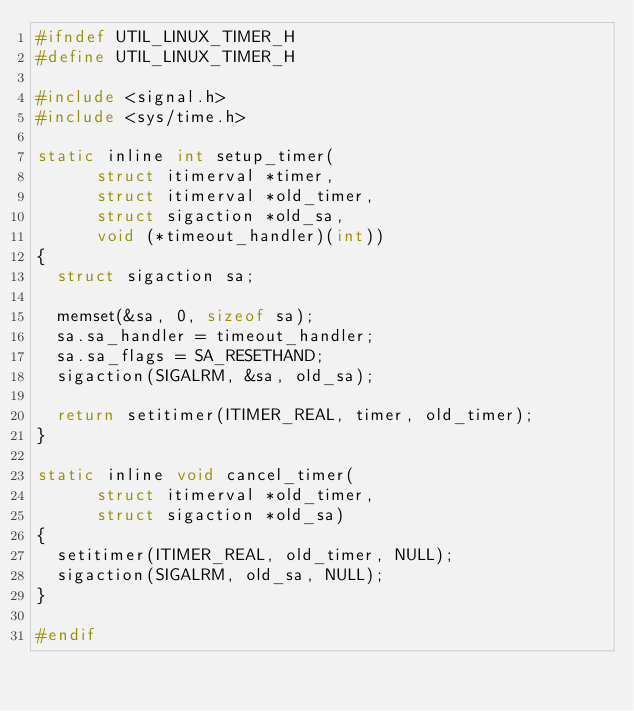<code> <loc_0><loc_0><loc_500><loc_500><_C_>#ifndef UTIL_LINUX_TIMER_H
#define UTIL_LINUX_TIMER_H

#include <signal.h>
#include <sys/time.h>

static inline int setup_timer(
			struct itimerval *timer,
			struct itimerval *old_timer,
			struct sigaction *old_sa,
			void (*timeout_handler)(int))
{
	struct sigaction sa;

	memset(&sa, 0, sizeof sa);
	sa.sa_handler = timeout_handler;
	sa.sa_flags = SA_RESETHAND;
	sigaction(SIGALRM, &sa, old_sa);

	return setitimer(ITIMER_REAL, timer, old_timer);
}

static inline void cancel_timer(
			struct itimerval *old_timer,
			struct sigaction *old_sa)
{
	setitimer(ITIMER_REAL, old_timer, NULL);
	sigaction(SIGALRM, old_sa, NULL);
}

#endif
</code> 